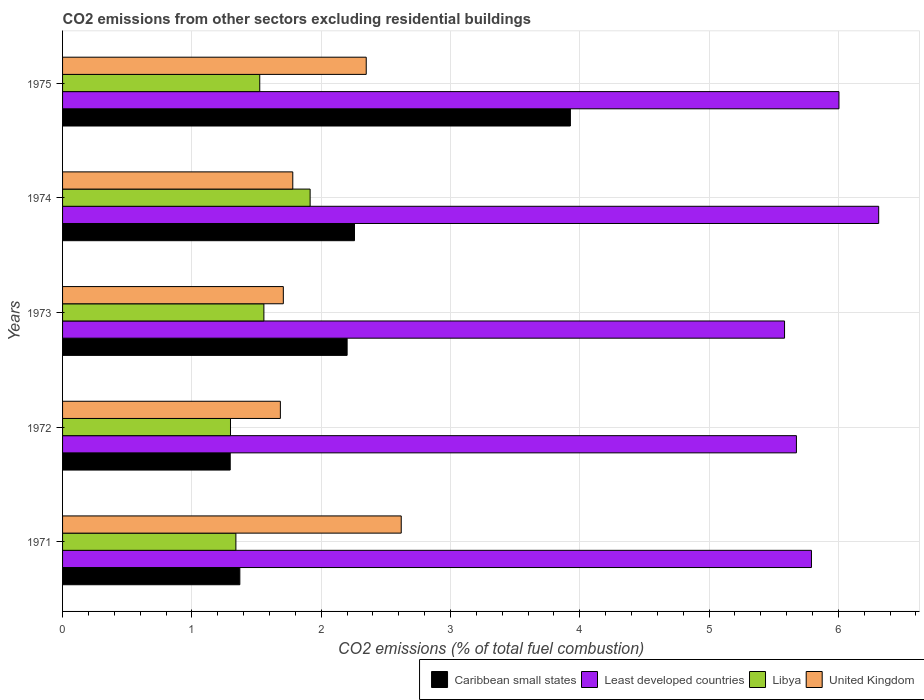Are the number of bars on each tick of the Y-axis equal?
Your response must be concise. Yes. How many bars are there on the 1st tick from the top?
Keep it short and to the point. 4. What is the label of the 3rd group of bars from the top?
Your answer should be very brief. 1973. In how many cases, is the number of bars for a given year not equal to the number of legend labels?
Your answer should be compact. 0. What is the total CO2 emitted in Least developed countries in 1971?
Your answer should be very brief. 5.79. Across all years, what is the maximum total CO2 emitted in United Kingdom?
Ensure brevity in your answer.  2.62. Across all years, what is the minimum total CO2 emitted in Libya?
Ensure brevity in your answer.  1.3. In which year was the total CO2 emitted in Least developed countries maximum?
Provide a succinct answer. 1974. What is the total total CO2 emitted in Caribbean small states in the graph?
Provide a succinct answer. 11.05. What is the difference between the total CO2 emitted in Caribbean small states in 1971 and that in 1973?
Keep it short and to the point. -0.83. What is the difference between the total CO2 emitted in Least developed countries in 1975 and the total CO2 emitted in United Kingdom in 1972?
Provide a short and direct response. 4.32. What is the average total CO2 emitted in Caribbean small states per year?
Provide a succinct answer. 2.21. In the year 1975, what is the difference between the total CO2 emitted in Least developed countries and total CO2 emitted in Caribbean small states?
Provide a succinct answer. 2.08. What is the ratio of the total CO2 emitted in United Kingdom in 1973 to that in 1974?
Keep it short and to the point. 0.96. What is the difference between the highest and the second highest total CO2 emitted in United Kingdom?
Give a very brief answer. 0.27. What is the difference between the highest and the lowest total CO2 emitted in United Kingdom?
Provide a succinct answer. 0.93. In how many years, is the total CO2 emitted in Caribbean small states greater than the average total CO2 emitted in Caribbean small states taken over all years?
Your answer should be compact. 2. Is it the case that in every year, the sum of the total CO2 emitted in Caribbean small states and total CO2 emitted in United Kingdom is greater than the sum of total CO2 emitted in Least developed countries and total CO2 emitted in Libya?
Give a very brief answer. Yes. What does the 2nd bar from the top in 1974 represents?
Offer a very short reply. Libya. What does the 1st bar from the bottom in 1971 represents?
Ensure brevity in your answer.  Caribbean small states. Is it the case that in every year, the sum of the total CO2 emitted in Caribbean small states and total CO2 emitted in Least developed countries is greater than the total CO2 emitted in Libya?
Offer a very short reply. Yes. How many bars are there?
Offer a terse response. 20. Are the values on the major ticks of X-axis written in scientific E-notation?
Give a very brief answer. No. Where does the legend appear in the graph?
Your answer should be very brief. Bottom right. How many legend labels are there?
Your answer should be very brief. 4. How are the legend labels stacked?
Ensure brevity in your answer.  Horizontal. What is the title of the graph?
Make the answer very short. CO2 emissions from other sectors excluding residential buildings. Does "Latin America(developing only)" appear as one of the legend labels in the graph?
Give a very brief answer. No. What is the label or title of the X-axis?
Keep it short and to the point. CO2 emissions (% of total fuel combustion). What is the label or title of the Y-axis?
Your response must be concise. Years. What is the CO2 emissions (% of total fuel combustion) of Caribbean small states in 1971?
Offer a very short reply. 1.37. What is the CO2 emissions (% of total fuel combustion) in Least developed countries in 1971?
Make the answer very short. 5.79. What is the CO2 emissions (% of total fuel combustion) of Libya in 1971?
Offer a very short reply. 1.34. What is the CO2 emissions (% of total fuel combustion) of United Kingdom in 1971?
Keep it short and to the point. 2.62. What is the CO2 emissions (% of total fuel combustion) of Caribbean small states in 1972?
Your answer should be very brief. 1.3. What is the CO2 emissions (% of total fuel combustion) in Least developed countries in 1972?
Provide a short and direct response. 5.68. What is the CO2 emissions (% of total fuel combustion) of Libya in 1972?
Give a very brief answer. 1.3. What is the CO2 emissions (% of total fuel combustion) of United Kingdom in 1972?
Offer a very short reply. 1.68. What is the CO2 emissions (% of total fuel combustion) of Caribbean small states in 1973?
Give a very brief answer. 2.2. What is the CO2 emissions (% of total fuel combustion) in Least developed countries in 1973?
Give a very brief answer. 5.58. What is the CO2 emissions (% of total fuel combustion) of Libya in 1973?
Your response must be concise. 1.56. What is the CO2 emissions (% of total fuel combustion) of United Kingdom in 1973?
Make the answer very short. 1.71. What is the CO2 emissions (% of total fuel combustion) in Caribbean small states in 1974?
Make the answer very short. 2.26. What is the CO2 emissions (% of total fuel combustion) in Least developed countries in 1974?
Ensure brevity in your answer.  6.31. What is the CO2 emissions (% of total fuel combustion) in Libya in 1974?
Ensure brevity in your answer.  1.91. What is the CO2 emissions (% of total fuel combustion) in United Kingdom in 1974?
Give a very brief answer. 1.78. What is the CO2 emissions (% of total fuel combustion) of Caribbean small states in 1975?
Provide a succinct answer. 3.93. What is the CO2 emissions (% of total fuel combustion) of Least developed countries in 1975?
Your answer should be very brief. 6. What is the CO2 emissions (% of total fuel combustion) in Libya in 1975?
Give a very brief answer. 1.53. What is the CO2 emissions (% of total fuel combustion) of United Kingdom in 1975?
Provide a succinct answer. 2.35. Across all years, what is the maximum CO2 emissions (% of total fuel combustion) in Caribbean small states?
Provide a succinct answer. 3.93. Across all years, what is the maximum CO2 emissions (% of total fuel combustion) of Least developed countries?
Offer a very short reply. 6.31. Across all years, what is the maximum CO2 emissions (% of total fuel combustion) of Libya?
Give a very brief answer. 1.91. Across all years, what is the maximum CO2 emissions (% of total fuel combustion) of United Kingdom?
Ensure brevity in your answer.  2.62. Across all years, what is the minimum CO2 emissions (% of total fuel combustion) of Caribbean small states?
Your response must be concise. 1.3. Across all years, what is the minimum CO2 emissions (% of total fuel combustion) of Least developed countries?
Provide a short and direct response. 5.58. Across all years, what is the minimum CO2 emissions (% of total fuel combustion) in Libya?
Provide a short and direct response. 1.3. Across all years, what is the minimum CO2 emissions (% of total fuel combustion) in United Kingdom?
Make the answer very short. 1.68. What is the total CO2 emissions (% of total fuel combustion) of Caribbean small states in the graph?
Your answer should be very brief. 11.05. What is the total CO2 emissions (% of total fuel combustion) of Least developed countries in the graph?
Your answer should be very brief. 29.37. What is the total CO2 emissions (% of total fuel combustion) of Libya in the graph?
Offer a very short reply. 7.64. What is the total CO2 emissions (% of total fuel combustion) in United Kingdom in the graph?
Provide a short and direct response. 10.14. What is the difference between the CO2 emissions (% of total fuel combustion) in Caribbean small states in 1971 and that in 1972?
Keep it short and to the point. 0.07. What is the difference between the CO2 emissions (% of total fuel combustion) of Least developed countries in 1971 and that in 1972?
Your answer should be very brief. 0.12. What is the difference between the CO2 emissions (% of total fuel combustion) in Libya in 1971 and that in 1972?
Ensure brevity in your answer.  0.04. What is the difference between the CO2 emissions (% of total fuel combustion) in United Kingdom in 1971 and that in 1972?
Your answer should be very brief. 0.93. What is the difference between the CO2 emissions (% of total fuel combustion) in Caribbean small states in 1971 and that in 1973?
Your response must be concise. -0.83. What is the difference between the CO2 emissions (% of total fuel combustion) in Least developed countries in 1971 and that in 1973?
Make the answer very short. 0.21. What is the difference between the CO2 emissions (% of total fuel combustion) of Libya in 1971 and that in 1973?
Keep it short and to the point. -0.22. What is the difference between the CO2 emissions (% of total fuel combustion) in United Kingdom in 1971 and that in 1973?
Your response must be concise. 0.91. What is the difference between the CO2 emissions (% of total fuel combustion) in Caribbean small states in 1971 and that in 1974?
Your answer should be very brief. -0.89. What is the difference between the CO2 emissions (% of total fuel combustion) in Least developed countries in 1971 and that in 1974?
Your answer should be compact. -0.52. What is the difference between the CO2 emissions (% of total fuel combustion) of Libya in 1971 and that in 1974?
Ensure brevity in your answer.  -0.57. What is the difference between the CO2 emissions (% of total fuel combustion) in United Kingdom in 1971 and that in 1974?
Ensure brevity in your answer.  0.84. What is the difference between the CO2 emissions (% of total fuel combustion) of Caribbean small states in 1971 and that in 1975?
Offer a terse response. -2.56. What is the difference between the CO2 emissions (% of total fuel combustion) of Least developed countries in 1971 and that in 1975?
Your answer should be very brief. -0.21. What is the difference between the CO2 emissions (% of total fuel combustion) in Libya in 1971 and that in 1975?
Your answer should be very brief. -0.18. What is the difference between the CO2 emissions (% of total fuel combustion) of United Kingdom in 1971 and that in 1975?
Provide a succinct answer. 0.27. What is the difference between the CO2 emissions (% of total fuel combustion) of Caribbean small states in 1972 and that in 1973?
Your answer should be very brief. -0.9. What is the difference between the CO2 emissions (% of total fuel combustion) in Least developed countries in 1972 and that in 1973?
Provide a succinct answer. 0.09. What is the difference between the CO2 emissions (% of total fuel combustion) of Libya in 1972 and that in 1973?
Provide a short and direct response. -0.26. What is the difference between the CO2 emissions (% of total fuel combustion) of United Kingdom in 1972 and that in 1973?
Provide a short and direct response. -0.02. What is the difference between the CO2 emissions (% of total fuel combustion) of Caribbean small states in 1972 and that in 1974?
Make the answer very short. -0.96. What is the difference between the CO2 emissions (% of total fuel combustion) of Least developed countries in 1972 and that in 1974?
Your answer should be very brief. -0.64. What is the difference between the CO2 emissions (% of total fuel combustion) of Libya in 1972 and that in 1974?
Your answer should be compact. -0.62. What is the difference between the CO2 emissions (% of total fuel combustion) in United Kingdom in 1972 and that in 1974?
Your response must be concise. -0.1. What is the difference between the CO2 emissions (% of total fuel combustion) of Caribbean small states in 1972 and that in 1975?
Your response must be concise. -2.63. What is the difference between the CO2 emissions (% of total fuel combustion) of Least developed countries in 1972 and that in 1975?
Ensure brevity in your answer.  -0.33. What is the difference between the CO2 emissions (% of total fuel combustion) of Libya in 1972 and that in 1975?
Your answer should be very brief. -0.23. What is the difference between the CO2 emissions (% of total fuel combustion) in United Kingdom in 1972 and that in 1975?
Your answer should be compact. -0.66. What is the difference between the CO2 emissions (% of total fuel combustion) of Caribbean small states in 1973 and that in 1974?
Make the answer very short. -0.06. What is the difference between the CO2 emissions (% of total fuel combustion) in Least developed countries in 1973 and that in 1974?
Keep it short and to the point. -0.73. What is the difference between the CO2 emissions (% of total fuel combustion) of Libya in 1973 and that in 1974?
Offer a terse response. -0.36. What is the difference between the CO2 emissions (% of total fuel combustion) of United Kingdom in 1973 and that in 1974?
Provide a short and direct response. -0.07. What is the difference between the CO2 emissions (% of total fuel combustion) in Caribbean small states in 1973 and that in 1975?
Make the answer very short. -1.73. What is the difference between the CO2 emissions (% of total fuel combustion) in Least developed countries in 1973 and that in 1975?
Your response must be concise. -0.42. What is the difference between the CO2 emissions (% of total fuel combustion) of Libya in 1973 and that in 1975?
Make the answer very short. 0.03. What is the difference between the CO2 emissions (% of total fuel combustion) in United Kingdom in 1973 and that in 1975?
Your answer should be very brief. -0.64. What is the difference between the CO2 emissions (% of total fuel combustion) in Caribbean small states in 1974 and that in 1975?
Give a very brief answer. -1.67. What is the difference between the CO2 emissions (% of total fuel combustion) in Least developed countries in 1974 and that in 1975?
Your answer should be compact. 0.31. What is the difference between the CO2 emissions (% of total fuel combustion) of Libya in 1974 and that in 1975?
Make the answer very short. 0.39. What is the difference between the CO2 emissions (% of total fuel combustion) in United Kingdom in 1974 and that in 1975?
Ensure brevity in your answer.  -0.57. What is the difference between the CO2 emissions (% of total fuel combustion) of Caribbean small states in 1971 and the CO2 emissions (% of total fuel combustion) of Least developed countries in 1972?
Offer a terse response. -4.3. What is the difference between the CO2 emissions (% of total fuel combustion) of Caribbean small states in 1971 and the CO2 emissions (% of total fuel combustion) of Libya in 1972?
Offer a terse response. 0.07. What is the difference between the CO2 emissions (% of total fuel combustion) of Caribbean small states in 1971 and the CO2 emissions (% of total fuel combustion) of United Kingdom in 1972?
Your response must be concise. -0.31. What is the difference between the CO2 emissions (% of total fuel combustion) in Least developed countries in 1971 and the CO2 emissions (% of total fuel combustion) in Libya in 1972?
Your answer should be compact. 4.49. What is the difference between the CO2 emissions (% of total fuel combustion) in Least developed countries in 1971 and the CO2 emissions (% of total fuel combustion) in United Kingdom in 1972?
Offer a very short reply. 4.11. What is the difference between the CO2 emissions (% of total fuel combustion) of Libya in 1971 and the CO2 emissions (% of total fuel combustion) of United Kingdom in 1972?
Give a very brief answer. -0.34. What is the difference between the CO2 emissions (% of total fuel combustion) in Caribbean small states in 1971 and the CO2 emissions (% of total fuel combustion) in Least developed countries in 1973?
Offer a very short reply. -4.21. What is the difference between the CO2 emissions (% of total fuel combustion) in Caribbean small states in 1971 and the CO2 emissions (% of total fuel combustion) in Libya in 1973?
Provide a short and direct response. -0.19. What is the difference between the CO2 emissions (% of total fuel combustion) of Caribbean small states in 1971 and the CO2 emissions (% of total fuel combustion) of United Kingdom in 1973?
Your response must be concise. -0.34. What is the difference between the CO2 emissions (% of total fuel combustion) in Least developed countries in 1971 and the CO2 emissions (% of total fuel combustion) in Libya in 1973?
Keep it short and to the point. 4.23. What is the difference between the CO2 emissions (% of total fuel combustion) of Least developed countries in 1971 and the CO2 emissions (% of total fuel combustion) of United Kingdom in 1973?
Your answer should be very brief. 4.08. What is the difference between the CO2 emissions (% of total fuel combustion) of Libya in 1971 and the CO2 emissions (% of total fuel combustion) of United Kingdom in 1973?
Ensure brevity in your answer.  -0.37. What is the difference between the CO2 emissions (% of total fuel combustion) in Caribbean small states in 1971 and the CO2 emissions (% of total fuel combustion) in Least developed countries in 1974?
Offer a terse response. -4.94. What is the difference between the CO2 emissions (% of total fuel combustion) in Caribbean small states in 1971 and the CO2 emissions (% of total fuel combustion) in Libya in 1974?
Your answer should be compact. -0.54. What is the difference between the CO2 emissions (% of total fuel combustion) in Caribbean small states in 1971 and the CO2 emissions (% of total fuel combustion) in United Kingdom in 1974?
Your response must be concise. -0.41. What is the difference between the CO2 emissions (% of total fuel combustion) of Least developed countries in 1971 and the CO2 emissions (% of total fuel combustion) of Libya in 1974?
Your answer should be very brief. 3.88. What is the difference between the CO2 emissions (% of total fuel combustion) in Least developed countries in 1971 and the CO2 emissions (% of total fuel combustion) in United Kingdom in 1974?
Your answer should be very brief. 4.01. What is the difference between the CO2 emissions (% of total fuel combustion) of Libya in 1971 and the CO2 emissions (% of total fuel combustion) of United Kingdom in 1974?
Make the answer very short. -0.44. What is the difference between the CO2 emissions (% of total fuel combustion) of Caribbean small states in 1971 and the CO2 emissions (% of total fuel combustion) of Least developed countries in 1975?
Your response must be concise. -4.63. What is the difference between the CO2 emissions (% of total fuel combustion) of Caribbean small states in 1971 and the CO2 emissions (% of total fuel combustion) of Libya in 1975?
Provide a succinct answer. -0.15. What is the difference between the CO2 emissions (% of total fuel combustion) in Caribbean small states in 1971 and the CO2 emissions (% of total fuel combustion) in United Kingdom in 1975?
Your answer should be compact. -0.98. What is the difference between the CO2 emissions (% of total fuel combustion) of Least developed countries in 1971 and the CO2 emissions (% of total fuel combustion) of Libya in 1975?
Give a very brief answer. 4.27. What is the difference between the CO2 emissions (% of total fuel combustion) of Least developed countries in 1971 and the CO2 emissions (% of total fuel combustion) of United Kingdom in 1975?
Give a very brief answer. 3.44. What is the difference between the CO2 emissions (% of total fuel combustion) in Libya in 1971 and the CO2 emissions (% of total fuel combustion) in United Kingdom in 1975?
Keep it short and to the point. -1.01. What is the difference between the CO2 emissions (% of total fuel combustion) of Caribbean small states in 1972 and the CO2 emissions (% of total fuel combustion) of Least developed countries in 1973?
Offer a very short reply. -4.29. What is the difference between the CO2 emissions (% of total fuel combustion) of Caribbean small states in 1972 and the CO2 emissions (% of total fuel combustion) of Libya in 1973?
Your answer should be compact. -0.26. What is the difference between the CO2 emissions (% of total fuel combustion) in Caribbean small states in 1972 and the CO2 emissions (% of total fuel combustion) in United Kingdom in 1973?
Your response must be concise. -0.41. What is the difference between the CO2 emissions (% of total fuel combustion) in Least developed countries in 1972 and the CO2 emissions (% of total fuel combustion) in Libya in 1973?
Offer a terse response. 4.12. What is the difference between the CO2 emissions (% of total fuel combustion) in Least developed countries in 1972 and the CO2 emissions (% of total fuel combustion) in United Kingdom in 1973?
Keep it short and to the point. 3.97. What is the difference between the CO2 emissions (% of total fuel combustion) of Libya in 1972 and the CO2 emissions (% of total fuel combustion) of United Kingdom in 1973?
Keep it short and to the point. -0.41. What is the difference between the CO2 emissions (% of total fuel combustion) of Caribbean small states in 1972 and the CO2 emissions (% of total fuel combustion) of Least developed countries in 1974?
Offer a terse response. -5.02. What is the difference between the CO2 emissions (% of total fuel combustion) of Caribbean small states in 1972 and the CO2 emissions (% of total fuel combustion) of Libya in 1974?
Keep it short and to the point. -0.62. What is the difference between the CO2 emissions (% of total fuel combustion) in Caribbean small states in 1972 and the CO2 emissions (% of total fuel combustion) in United Kingdom in 1974?
Provide a short and direct response. -0.48. What is the difference between the CO2 emissions (% of total fuel combustion) in Least developed countries in 1972 and the CO2 emissions (% of total fuel combustion) in Libya in 1974?
Offer a very short reply. 3.76. What is the difference between the CO2 emissions (% of total fuel combustion) in Least developed countries in 1972 and the CO2 emissions (% of total fuel combustion) in United Kingdom in 1974?
Give a very brief answer. 3.9. What is the difference between the CO2 emissions (% of total fuel combustion) in Libya in 1972 and the CO2 emissions (% of total fuel combustion) in United Kingdom in 1974?
Provide a short and direct response. -0.48. What is the difference between the CO2 emissions (% of total fuel combustion) of Caribbean small states in 1972 and the CO2 emissions (% of total fuel combustion) of Least developed countries in 1975?
Provide a short and direct response. -4.71. What is the difference between the CO2 emissions (% of total fuel combustion) of Caribbean small states in 1972 and the CO2 emissions (% of total fuel combustion) of Libya in 1975?
Keep it short and to the point. -0.23. What is the difference between the CO2 emissions (% of total fuel combustion) of Caribbean small states in 1972 and the CO2 emissions (% of total fuel combustion) of United Kingdom in 1975?
Keep it short and to the point. -1.05. What is the difference between the CO2 emissions (% of total fuel combustion) of Least developed countries in 1972 and the CO2 emissions (% of total fuel combustion) of Libya in 1975?
Your response must be concise. 4.15. What is the difference between the CO2 emissions (% of total fuel combustion) in Least developed countries in 1972 and the CO2 emissions (% of total fuel combustion) in United Kingdom in 1975?
Your response must be concise. 3.33. What is the difference between the CO2 emissions (% of total fuel combustion) of Libya in 1972 and the CO2 emissions (% of total fuel combustion) of United Kingdom in 1975?
Your answer should be compact. -1.05. What is the difference between the CO2 emissions (% of total fuel combustion) in Caribbean small states in 1973 and the CO2 emissions (% of total fuel combustion) in Least developed countries in 1974?
Keep it short and to the point. -4.11. What is the difference between the CO2 emissions (% of total fuel combustion) in Caribbean small states in 1973 and the CO2 emissions (% of total fuel combustion) in Libya in 1974?
Your answer should be compact. 0.29. What is the difference between the CO2 emissions (% of total fuel combustion) in Caribbean small states in 1973 and the CO2 emissions (% of total fuel combustion) in United Kingdom in 1974?
Provide a short and direct response. 0.42. What is the difference between the CO2 emissions (% of total fuel combustion) of Least developed countries in 1973 and the CO2 emissions (% of total fuel combustion) of Libya in 1974?
Offer a very short reply. 3.67. What is the difference between the CO2 emissions (% of total fuel combustion) in Least developed countries in 1973 and the CO2 emissions (% of total fuel combustion) in United Kingdom in 1974?
Provide a short and direct response. 3.8. What is the difference between the CO2 emissions (% of total fuel combustion) in Libya in 1973 and the CO2 emissions (% of total fuel combustion) in United Kingdom in 1974?
Offer a terse response. -0.22. What is the difference between the CO2 emissions (% of total fuel combustion) in Caribbean small states in 1973 and the CO2 emissions (% of total fuel combustion) in Least developed countries in 1975?
Your answer should be compact. -3.8. What is the difference between the CO2 emissions (% of total fuel combustion) in Caribbean small states in 1973 and the CO2 emissions (% of total fuel combustion) in Libya in 1975?
Ensure brevity in your answer.  0.68. What is the difference between the CO2 emissions (% of total fuel combustion) in Caribbean small states in 1973 and the CO2 emissions (% of total fuel combustion) in United Kingdom in 1975?
Your response must be concise. -0.15. What is the difference between the CO2 emissions (% of total fuel combustion) in Least developed countries in 1973 and the CO2 emissions (% of total fuel combustion) in Libya in 1975?
Offer a very short reply. 4.06. What is the difference between the CO2 emissions (% of total fuel combustion) of Least developed countries in 1973 and the CO2 emissions (% of total fuel combustion) of United Kingdom in 1975?
Give a very brief answer. 3.24. What is the difference between the CO2 emissions (% of total fuel combustion) of Libya in 1973 and the CO2 emissions (% of total fuel combustion) of United Kingdom in 1975?
Ensure brevity in your answer.  -0.79. What is the difference between the CO2 emissions (% of total fuel combustion) in Caribbean small states in 1974 and the CO2 emissions (% of total fuel combustion) in Least developed countries in 1975?
Give a very brief answer. -3.75. What is the difference between the CO2 emissions (% of total fuel combustion) of Caribbean small states in 1974 and the CO2 emissions (% of total fuel combustion) of Libya in 1975?
Your answer should be very brief. 0.73. What is the difference between the CO2 emissions (% of total fuel combustion) of Caribbean small states in 1974 and the CO2 emissions (% of total fuel combustion) of United Kingdom in 1975?
Your answer should be very brief. -0.09. What is the difference between the CO2 emissions (% of total fuel combustion) in Least developed countries in 1974 and the CO2 emissions (% of total fuel combustion) in Libya in 1975?
Your answer should be very brief. 4.79. What is the difference between the CO2 emissions (% of total fuel combustion) in Least developed countries in 1974 and the CO2 emissions (% of total fuel combustion) in United Kingdom in 1975?
Your response must be concise. 3.96. What is the difference between the CO2 emissions (% of total fuel combustion) in Libya in 1974 and the CO2 emissions (% of total fuel combustion) in United Kingdom in 1975?
Provide a succinct answer. -0.43. What is the average CO2 emissions (% of total fuel combustion) of Caribbean small states per year?
Give a very brief answer. 2.21. What is the average CO2 emissions (% of total fuel combustion) of Least developed countries per year?
Provide a succinct answer. 5.87. What is the average CO2 emissions (% of total fuel combustion) of Libya per year?
Make the answer very short. 1.53. What is the average CO2 emissions (% of total fuel combustion) in United Kingdom per year?
Ensure brevity in your answer.  2.03. In the year 1971, what is the difference between the CO2 emissions (% of total fuel combustion) in Caribbean small states and CO2 emissions (% of total fuel combustion) in Least developed countries?
Give a very brief answer. -4.42. In the year 1971, what is the difference between the CO2 emissions (% of total fuel combustion) of Caribbean small states and CO2 emissions (% of total fuel combustion) of Libya?
Keep it short and to the point. 0.03. In the year 1971, what is the difference between the CO2 emissions (% of total fuel combustion) of Caribbean small states and CO2 emissions (% of total fuel combustion) of United Kingdom?
Your answer should be very brief. -1.25. In the year 1971, what is the difference between the CO2 emissions (% of total fuel combustion) in Least developed countries and CO2 emissions (% of total fuel combustion) in Libya?
Keep it short and to the point. 4.45. In the year 1971, what is the difference between the CO2 emissions (% of total fuel combustion) of Least developed countries and CO2 emissions (% of total fuel combustion) of United Kingdom?
Your answer should be compact. 3.17. In the year 1971, what is the difference between the CO2 emissions (% of total fuel combustion) in Libya and CO2 emissions (% of total fuel combustion) in United Kingdom?
Make the answer very short. -1.28. In the year 1972, what is the difference between the CO2 emissions (% of total fuel combustion) in Caribbean small states and CO2 emissions (% of total fuel combustion) in Least developed countries?
Your answer should be compact. -4.38. In the year 1972, what is the difference between the CO2 emissions (% of total fuel combustion) of Caribbean small states and CO2 emissions (% of total fuel combustion) of Libya?
Provide a succinct answer. -0. In the year 1972, what is the difference between the CO2 emissions (% of total fuel combustion) of Caribbean small states and CO2 emissions (% of total fuel combustion) of United Kingdom?
Your answer should be very brief. -0.39. In the year 1972, what is the difference between the CO2 emissions (% of total fuel combustion) in Least developed countries and CO2 emissions (% of total fuel combustion) in Libya?
Offer a terse response. 4.38. In the year 1972, what is the difference between the CO2 emissions (% of total fuel combustion) of Least developed countries and CO2 emissions (% of total fuel combustion) of United Kingdom?
Your answer should be very brief. 3.99. In the year 1972, what is the difference between the CO2 emissions (% of total fuel combustion) of Libya and CO2 emissions (% of total fuel combustion) of United Kingdom?
Keep it short and to the point. -0.39. In the year 1973, what is the difference between the CO2 emissions (% of total fuel combustion) in Caribbean small states and CO2 emissions (% of total fuel combustion) in Least developed countries?
Provide a short and direct response. -3.38. In the year 1973, what is the difference between the CO2 emissions (% of total fuel combustion) of Caribbean small states and CO2 emissions (% of total fuel combustion) of Libya?
Make the answer very short. 0.64. In the year 1973, what is the difference between the CO2 emissions (% of total fuel combustion) of Caribbean small states and CO2 emissions (% of total fuel combustion) of United Kingdom?
Your response must be concise. 0.49. In the year 1973, what is the difference between the CO2 emissions (% of total fuel combustion) of Least developed countries and CO2 emissions (% of total fuel combustion) of Libya?
Make the answer very short. 4.03. In the year 1973, what is the difference between the CO2 emissions (% of total fuel combustion) in Least developed countries and CO2 emissions (% of total fuel combustion) in United Kingdom?
Ensure brevity in your answer.  3.88. In the year 1973, what is the difference between the CO2 emissions (% of total fuel combustion) in Libya and CO2 emissions (% of total fuel combustion) in United Kingdom?
Ensure brevity in your answer.  -0.15. In the year 1974, what is the difference between the CO2 emissions (% of total fuel combustion) in Caribbean small states and CO2 emissions (% of total fuel combustion) in Least developed countries?
Ensure brevity in your answer.  -4.05. In the year 1974, what is the difference between the CO2 emissions (% of total fuel combustion) of Caribbean small states and CO2 emissions (% of total fuel combustion) of Libya?
Ensure brevity in your answer.  0.34. In the year 1974, what is the difference between the CO2 emissions (% of total fuel combustion) in Caribbean small states and CO2 emissions (% of total fuel combustion) in United Kingdom?
Make the answer very short. 0.48. In the year 1974, what is the difference between the CO2 emissions (% of total fuel combustion) in Least developed countries and CO2 emissions (% of total fuel combustion) in Libya?
Keep it short and to the point. 4.4. In the year 1974, what is the difference between the CO2 emissions (% of total fuel combustion) in Least developed countries and CO2 emissions (% of total fuel combustion) in United Kingdom?
Your answer should be very brief. 4.53. In the year 1974, what is the difference between the CO2 emissions (% of total fuel combustion) of Libya and CO2 emissions (% of total fuel combustion) of United Kingdom?
Keep it short and to the point. 0.13. In the year 1975, what is the difference between the CO2 emissions (% of total fuel combustion) of Caribbean small states and CO2 emissions (% of total fuel combustion) of Least developed countries?
Keep it short and to the point. -2.08. In the year 1975, what is the difference between the CO2 emissions (% of total fuel combustion) of Caribbean small states and CO2 emissions (% of total fuel combustion) of Libya?
Your response must be concise. 2.4. In the year 1975, what is the difference between the CO2 emissions (% of total fuel combustion) in Caribbean small states and CO2 emissions (% of total fuel combustion) in United Kingdom?
Ensure brevity in your answer.  1.58. In the year 1975, what is the difference between the CO2 emissions (% of total fuel combustion) of Least developed countries and CO2 emissions (% of total fuel combustion) of Libya?
Offer a terse response. 4.48. In the year 1975, what is the difference between the CO2 emissions (% of total fuel combustion) of Least developed countries and CO2 emissions (% of total fuel combustion) of United Kingdom?
Your response must be concise. 3.66. In the year 1975, what is the difference between the CO2 emissions (% of total fuel combustion) in Libya and CO2 emissions (% of total fuel combustion) in United Kingdom?
Your response must be concise. -0.82. What is the ratio of the CO2 emissions (% of total fuel combustion) in Caribbean small states in 1971 to that in 1972?
Make the answer very short. 1.06. What is the ratio of the CO2 emissions (% of total fuel combustion) of Least developed countries in 1971 to that in 1972?
Provide a short and direct response. 1.02. What is the ratio of the CO2 emissions (% of total fuel combustion) of Libya in 1971 to that in 1972?
Offer a terse response. 1.03. What is the ratio of the CO2 emissions (% of total fuel combustion) of United Kingdom in 1971 to that in 1972?
Provide a short and direct response. 1.55. What is the ratio of the CO2 emissions (% of total fuel combustion) in Caribbean small states in 1971 to that in 1973?
Give a very brief answer. 0.62. What is the ratio of the CO2 emissions (% of total fuel combustion) of Least developed countries in 1971 to that in 1973?
Offer a very short reply. 1.04. What is the ratio of the CO2 emissions (% of total fuel combustion) of Libya in 1971 to that in 1973?
Provide a succinct answer. 0.86. What is the ratio of the CO2 emissions (% of total fuel combustion) in United Kingdom in 1971 to that in 1973?
Your response must be concise. 1.53. What is the ratio of the CO2 emissions (% of total fuel combustion) of Caribbean small states in 1971 to that in 1974?
Your answer should be very brief. 0.61. What is the ratio of the CO2 emissions (% of total fuel combustion) of Least developed countries in 1971 to that in 1974?
Your answer should be compact. 0.92. What is the ratio of the CO2 emissions (% of total fuel combustion) in Libya in 1971 to that in 1974?
Give a very brief answer. 0.7. What is the ratio of the CO2 emissions (% of total fuel combustion) of United Kingdom in 1971 to that in 1974?
Provide a short and direct response. 1.47. What is the ratio of the CO2 emissions (% of total fuel combustion) of Caribbean small states in 1971 to that in 1975?
Offer a terse response. 0.35. What is the ratio of the CO2 emissions (% of total fuel combustion) of Least developed countries in 1971 to that in 1975?
Make the answer very short. 0.96. What is the ratio of the CO2 emissions (% of total fuel combustion) in Libya in 1971 to that in 1975?
Your answer should be compact. 0.88. What is the ratio of the CO2 emissions (% of total fuel combustion) of United Kingdom in 1971 to that in 1975?
Ensure brevity in your answer.  1.12. What is the ratio of the CO2 emissions (% of total fuel combustion) in Caribbean small states in 1972 to that in 1973?
Ensure brevity in your answer.  0.59. What is the ratio of the CO2 emissions (% of total fuel combustion) of Least developed countries in 1972 to that in 1973?
Provide a short and direct response. 1.02. What is the ratio of the CO2 emissions (% of total fuel combustion) in Libya in 1972 to that in 1973?
Your answer should be very brief. 0.83. What is the ratio of the CO2 emissions (% of total fuel combustion) in United Kingdom in 1972 to that in 1973?
Ensure brevity in your answer.  0.99. What is the ratio of the CO2 emissions (% of total fuel combustion) in Caribbean small states in 1972 to that in 1974?
Keep it short and to the point. 0.57. What is the ratio of the CO2 emissions (% of total fuel combustion) of Least developed countries in 1972 to that in 1974?
Your answer should be compact. 0.9. What is the ratio of the CO2 emissions (% of total fuel combustion) in Libya in 1972 to that in 1974?
Your response must be concise. 0.68. What is the ratio of the CO2 emissions (% of total fuel combustion) in United Kingdom in 1972 to that in 1974?
Offer a very short reply. 0.95. What is the ratio of the CO2 emissions (% of total fuel combustion) in Caribbean small states in 1972 to that in 1975?
Make the answer very short. 0.33. What is the ratio of the CO2 emissions (% of total fuel combustion) of Least developed countries in 1972 to that in 1975?
Your answer should be compact. 0.95. What is the ratio of the CO2 emissions (% of total fuel combustion) in Libya in 1972 to that in 1975?
Your response must be concise. 0.85. What is the ratio of the CO2 emissions (% of total fuel combustion) of United Kingdom in 1972 to that in 1975?
Your answer should be very brief. 0.72. What is the ratio of the CO2 emissions (% of total fuel combustion) in Caribbean small states in 1973 to that in 1974?
Provide a short and direct response. 0.97. What is the ratio of the CO2 emissions (% of total fuel combustion) in Least developed countries in 1973 to that in 1974?
Your answer should be compact. 0.88. What is the ratio of the CO2 emissions (% of total fuel combustion) in Libya in 1973 to that in 1974?
Make the answer very short. 0.81. What is the ratio of the CO2 emissions (% of total fuel combustion) of United Kingdom in 1973 to that in 1974?
Ensure brevity in your answer.  0.96. What is the ratio of the CO2 emissions (% of total fuel combustion) of Caribbean small states in 1973 to that in 1975?
Provide a succinct answer. 0.56. What is the ratio of the CO2 emissions (% of total fuel combustion) of Least developed countries in 1973 to that in 1975?
Provide a succinct answer. 0.93. What is the ratio of the CO2 emissions (% of total fuel combustion) in Libya in 1973 to that in 1975?
Your answer should be compact. 1.02. What is the ratio of the CO2 emissions (% of total fuel combustion) of United Kingdom in 1973 to that in 1975?
Provide a short and direct response. 0.73. What is the ratio of the CO2 emissions (% of total fuel combustion) in Caribbean small states in 1974 to that in 1975?
Provide a short and direct response. 0.57. What is the ratio of the CO2 emissions (% of total fuel combustion) in Least developed countries in 1974 to that in 1975?
Your answer should be compact. 1.05. What is the ratio of the CO2 emissions (% of total fuel combustion) of Libya in 1974 to that in 1975?
Give a very brief answer. 1.26. What is the ratio of the CO2 emissions (% of total fuel combustion) in United Kingdom in 1974 to that in 1975?
Make the answer very short. 0.76. What is the difference between the highest and the second highest CO2 emissions (% of total fuel combustion) in Caribbean small states?
Provide a succinct answer. 1.67. What is the difference between the highest and the second highest CO2 emissions (% of total fuel combustion) in Least developed countries?
Your response must be concise. 0.31. What is the difference between the highest and the second highest CO2 emissions (% of total fuel combustion) of Libya?
Ensure brevity in your answer.  0.36. What is the difference between the highest and the second highest CO2 emissions (% of total fuel combustion) of United Kingdom?
Offer a very short reply. 0.27. What is the difference between the highest and the lowest CO2 emissions (% of total fuel combustion) in Caribbean small states?
Make the answer very short. 2.63. What is the difference between the highest and the lowest CO2 emissions (% of total fuel combustion) in Least developed countries?
Your answer should be compact. 0.73. What is the difference between the highest and the lowest CO2 emissions (% of total fuel combustion) of Libya?
Make the answer very short. 0.62. What is the difference between the highest and the lowest CO2 emissions (% of total fuel combustion) in United Kingdom?
Keep it short and to the point. 0.93. 